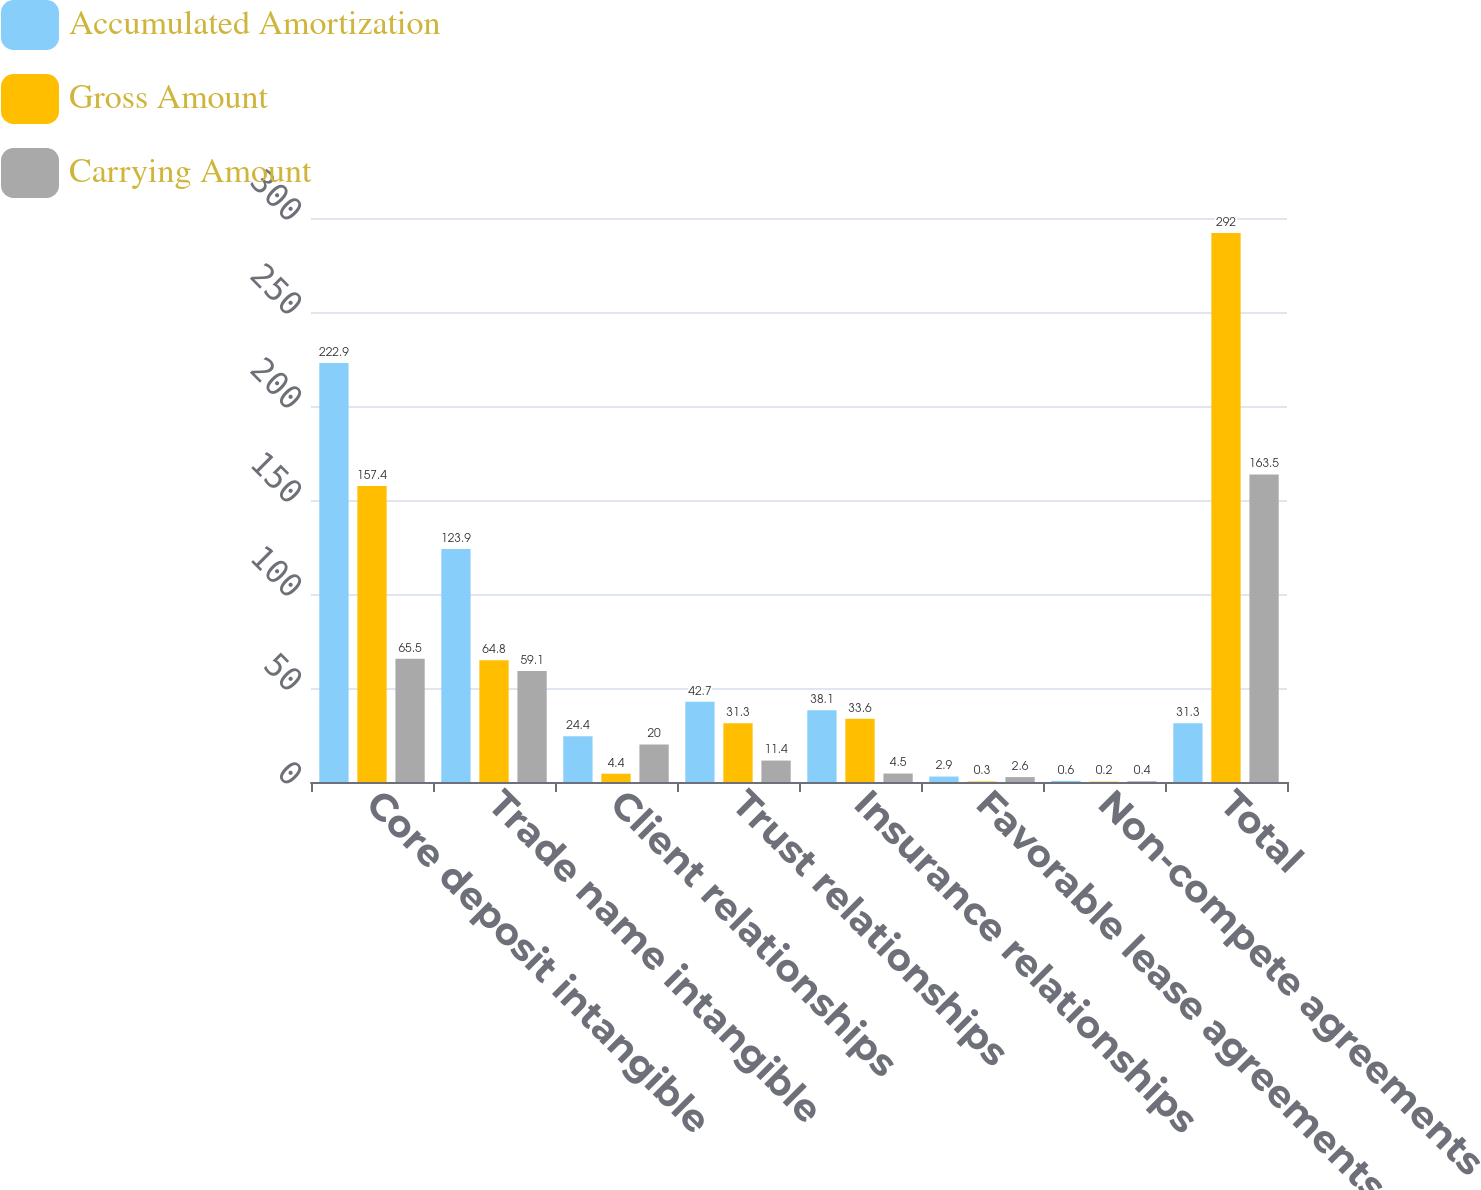<chart> <loc_0><loc_0><loc_500><loc_500><stacked_bar_chart><ecel><fcel>Core deposit intangible<fcel>Trade name intangible<fcel>Client relationships<fcel>Trust relationships<fcel>Insurance relationships<fcel>Favorable lease agreements<fcel>Non-compete agreements<fcel>Total<nl><fcel>Accumulated Amortization<fcel>222.9<fcel>123.9<fcel>24.4<fcel>42.7<fcel>38.1<fcel>2.9<fcel>0.6<fcel>31.3<nl><fcel>Gross Amount<fcel>157.4<fcel>64.8<fcel>4.4<fcel>31.3<fcel>33.6<fcel>0.3<fcel>0.2<fcel>292<nl><fcel>Carrying Amount<fcel>65.5<fcel>59.1<fcel>20<fcel>11.4<fcel>4.5<fcel>2.6<fcel>0.4<fcel>163.5<nl></chart> 